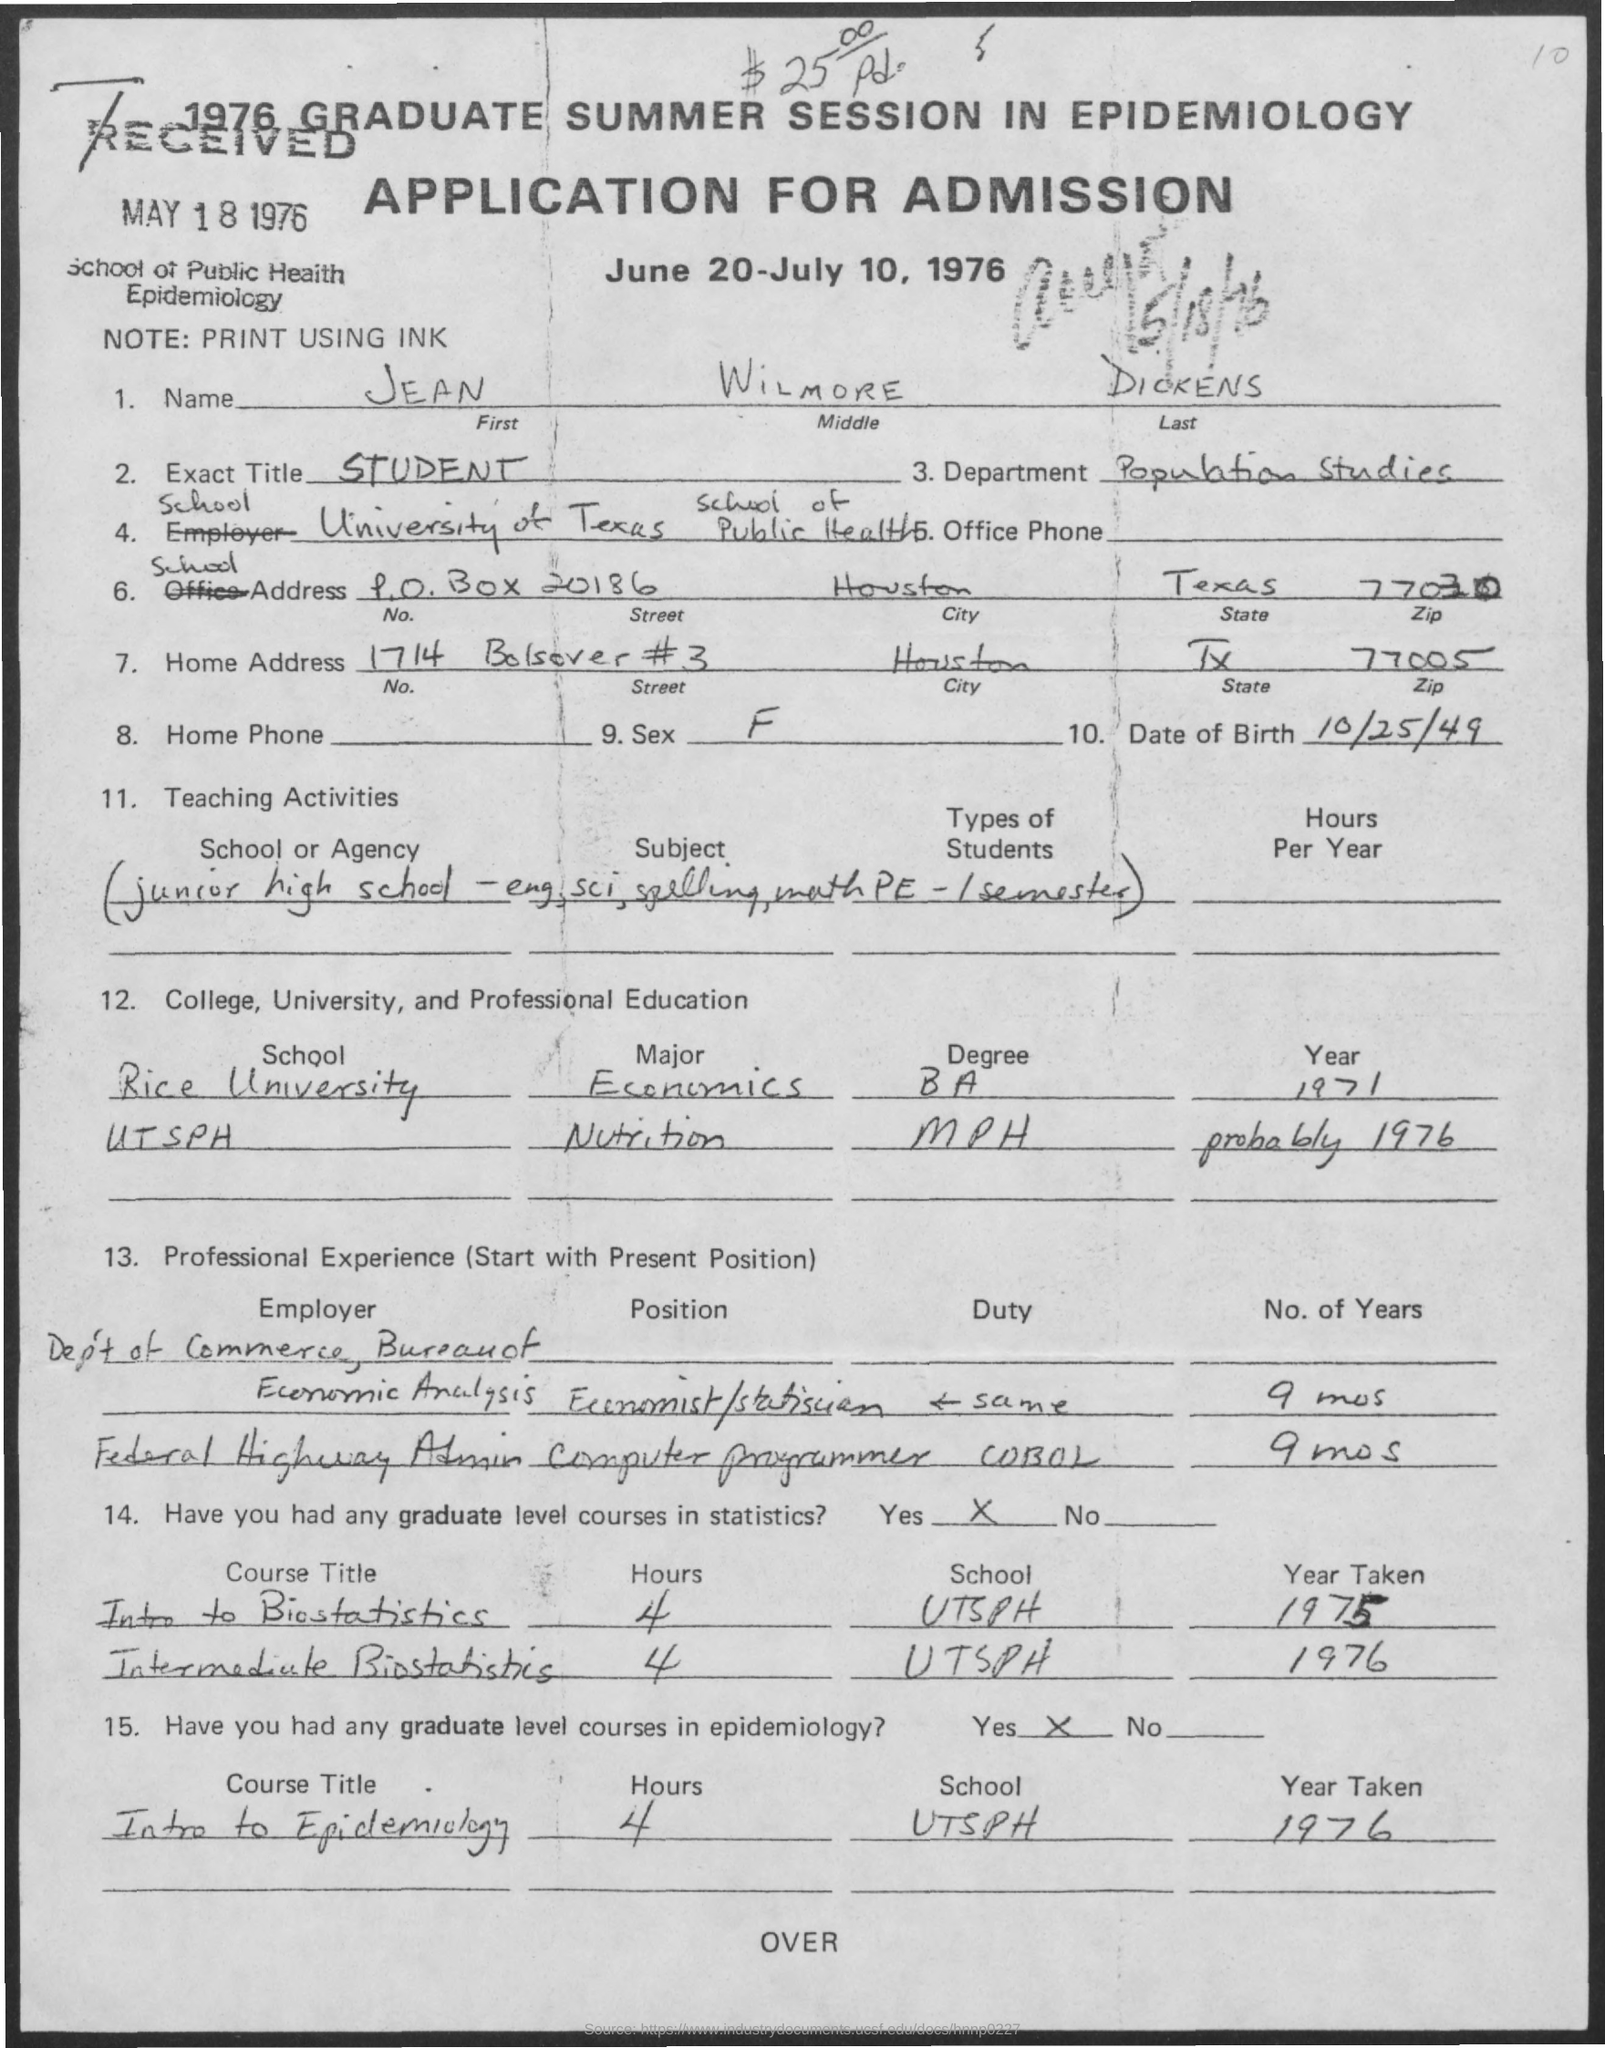Is there any previous professional experience listed for this applicant? Yes, the applicant has listed prior professional experience. They have worked in the Department of Commerce, Bureau of Economic Analysis as an Economist/Statistician for nine months, and as a Computer Programmer using COBOL at the Federal Highway Administration, also for nine months. 